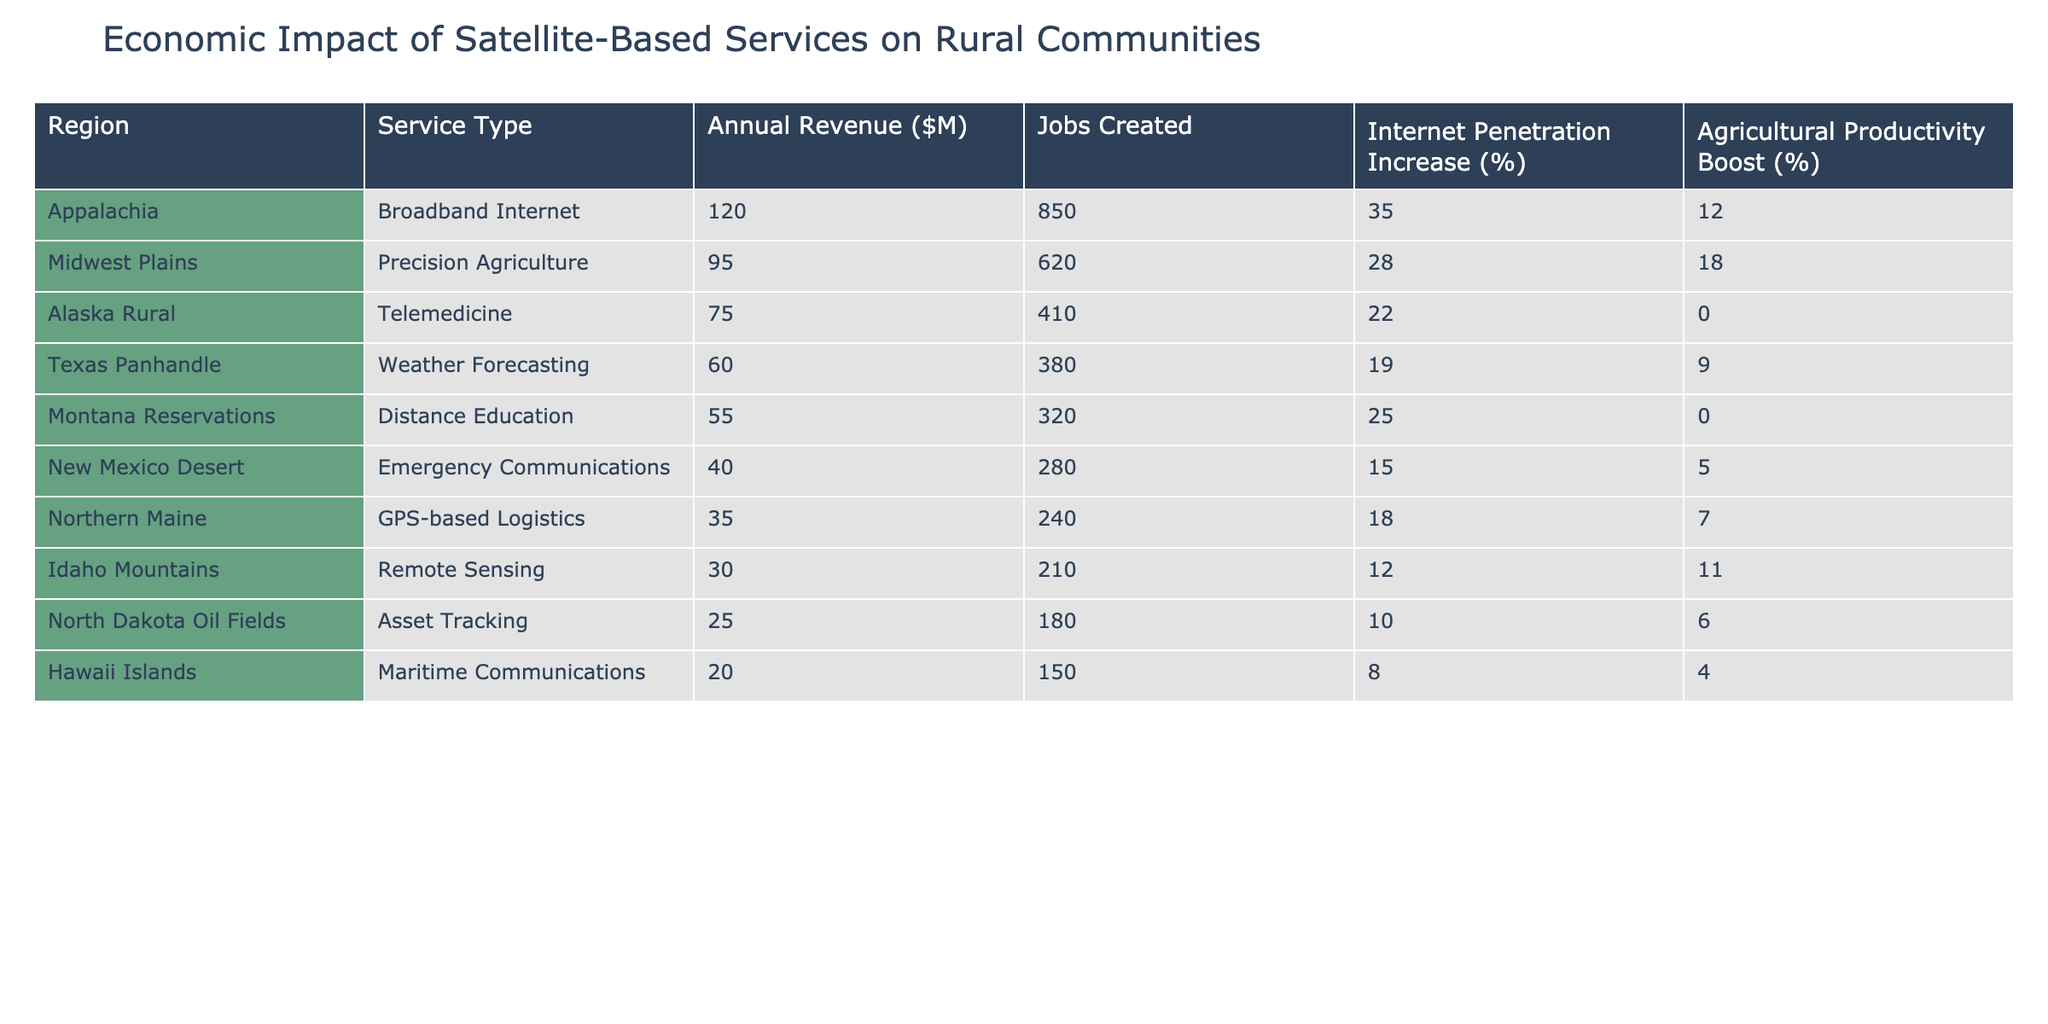What is the total annual revenue generated by satellite-based services in the Midwest Plains region? The table shows that the annual revenue for the Midwest Plains region's Precision Agriculture service is $95 million. Therefore, the total annual revenue generated in this region is simply the listed value.
Answer: $95 million Which service type in Appalachia has the highest internet penetration increase percentage? The table indicates that the Annual Revenue for Broadband Internet in Appalachia is $120 million, with an Internet Penetration Increase of 35%. This is the only service type listed for Appalachia, so it has the highest penetration increase percentage by default.
Answer: 35% What is the average number of jobs created by all the services listed in the table? To find the average, I will sum the jobs created across all regions: 850 + 620 + 410 + 380 + 320 + 280 + 240 + 210 + 180 + 150 = 3360. Since there are 10 regions, the average is 3360 / 10 = 336.
Answer: 336 In which region is the agricultural productivity boost the least? The table lists the agricultural productivity boost percentages for different regions. The lowest figure is 0%, found in Alaska Rural and Montana Reservations. Therefore, both regions have the least agricultural productivity boost.
Answer: Alaska Rural and Montana Reservations Do the Northern Maine services generate more revenue than those in Idaho Mountains? Northern Maine generates $35 million from GPS-based Logistics, while Idaho Mountains generates $30 million from Remote Sensing. Thus, Northern Maine does generate more revenue than Idaho Mountains.
Answer: Yes How many jobs are created by the precision agriculture service compared to the telemedicine service, and what is the difference? The jobs created by Precision Agriculture in the Midwest Plains is 620, and for Telemedicine in Alaska Rural, it's 410. The difference can be calculated as 620 - 410 = 210.
Answer: 210 Which region shows the highest boost in agricultural productivity, and how much is it? By checking the table, Precision Agriculture in the Midwest Plains shows an 18% agricultural productivity boost, which is the highest among all listed services.
Answer: 18% Is there any service that resulted in a 15% increase in internet penetration? The table indicates the internet penetration increase for the New Mexico Desert service as 15%. Therefore, there is indeed a service with this percentage increase.
Answer: Yes What is the combined annual revenue of the services that have job creation below 300? The regions with job creation below 300 are Northern Maine (240 jobs), Idaho Mountains (210 jobs), and Hawaii Islands (150 jobs). Their revenues are $35M, $30M, and $20M respectively. The combined revenue is 35 + 30 + 20 = 85 million.
Answer: $85 million Which service type has the highest combination of internet penetration increase and agricultural productivity boost? By looking at the internet penetration increase and agricultural productivity boost columns, we find that Precision Agriculture in Midwest Plains has an increase of 28% and a productivity boost of 18%. The total of both metrics is 46%. Thus, it has the highest combination value.
Answer: Precision Agriculture in Midwest Plains 